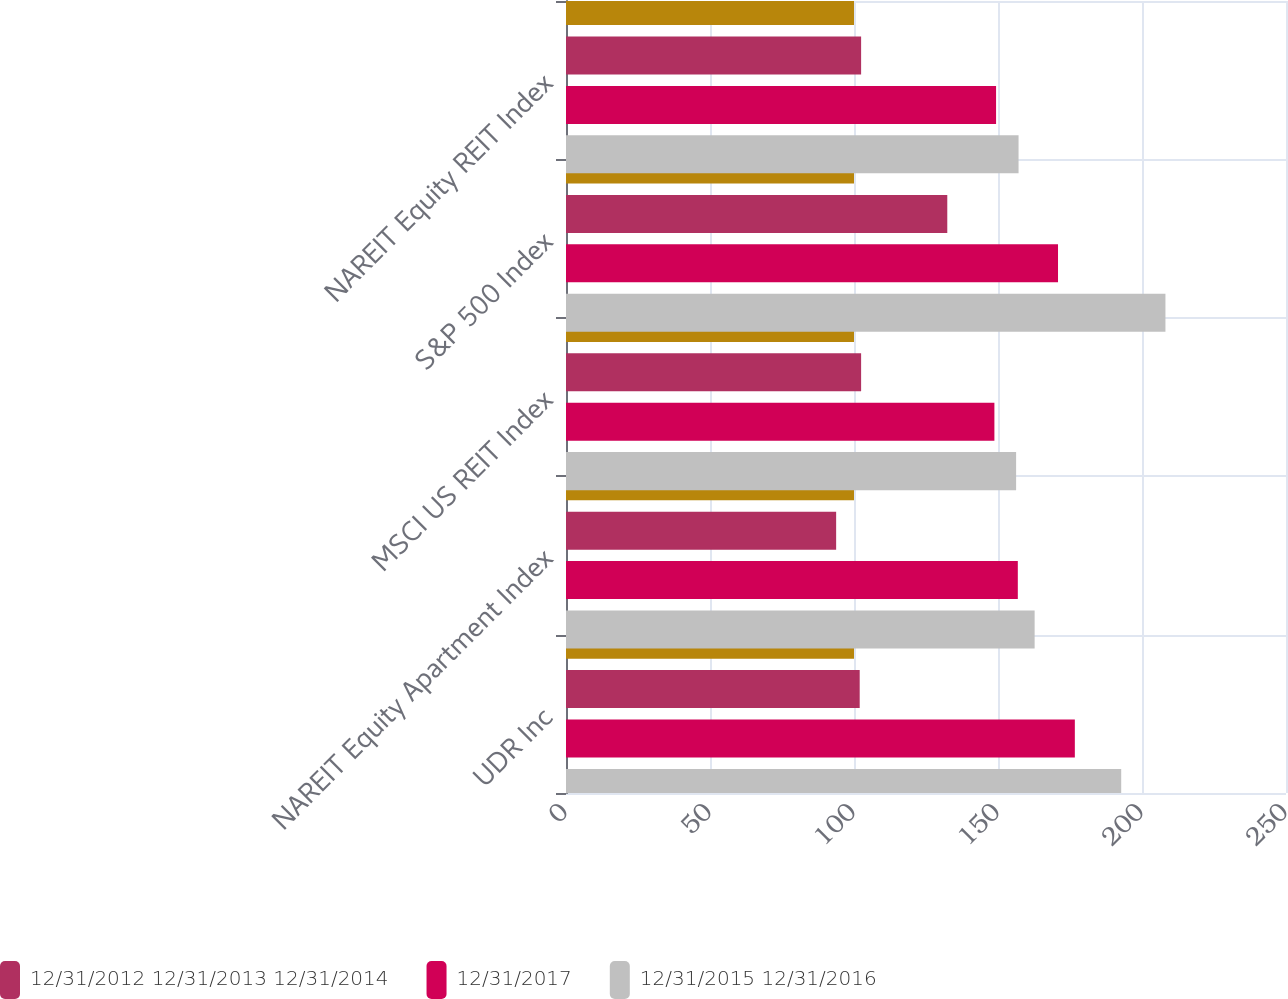Convert chart. <chart><loc_0><loc_0><loc_500><loc_500><stacked_bar_chart><ecel><fcel>UDR Inc<fcel>NAREIT Equity Apartment Index<fcel>MSCI US REIT Index<fcel>S&P 500 Index<fcel>NAREIT Equity REIT Index<nl><fcel>nan<fcel>100<fcel>100<fcel>100<fcel>100<fcel>100<nl><fcel>12/31/2012 12/31/2013 12/31/2014<fcel>101.98<fcel>93.8<fcel>102.47<fcel>132.39<fcel>102.47<nl><fcel>12/31/2017<fcel>176.68<fcel>156.88<fcel>148.75<fcel>170.84<fcel>149.33<nl><fcel>12/31/2015 12/31/2016<fcel>192.78<fcel>162.72<fcel>156.29<fcel>208.14<fcel>157.14<nl></chart> 